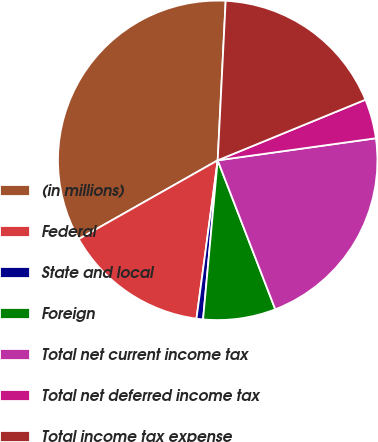Convert chart to OTSL. <chart><loc_0><loc_0><loc_500><loc_500><pie_chart><fcel>(in millions)<fcel>Federal<fcel>State and local<fcel>Foreign<fcel>Total net current income tax<fcel>Total net deferred income tax<fcel>Total income tax expense<nl><fcel>34.0%<fcel>14.68%<fcel>0.66%<fcel>7.33%<fcel>21.34%<fcel>3.99%<fcel>18.01%<nl></chart> 